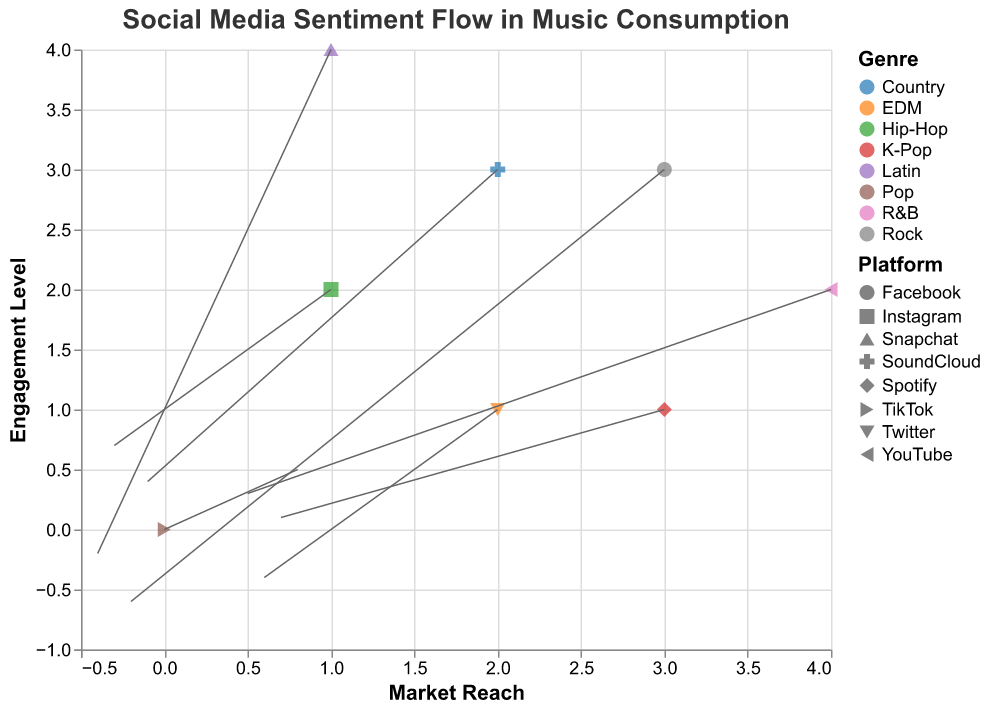Which social media platform is associated with the highest magnitude of sentiment flow? According to the tooltip of the data points, the platform associated with the highest magnitude of sentiment flow (1.2) is TikTok.
Answer: TikTok What is the direction of sentiment flow for Facebook in terms of Market Reach and Engagement Level? The data point for Facebook shows an arrow directed from (3, 3) towards negative x and y axes, meaning Market Reach decreases by 0.2 and Engagement Level decreases by 0.6.
Answer: Market Reach decreases and Engagement Level decreases Which genre shows sentiment flow with the greatest increase in Market Reach? Inspecting the U component of all genres, Pop has the greatest positive U value (0.8).
Answer: Pop How many data points have a sentiment flow magnitude over 1.0? Filtering the data points by Magnitude, we find that TikTok (Pop) with 1.2, Twitter (EDM) with 1.0, and Spotify (K-Pop) with 1.1 all exceed 1.0, yielding 3 data points.
Answer: 3 Which social media platform's sentiment flow in music consumption shows a negative change in Market Reach but a positive change in Engagement Level? Examining the U and V components of the data, Instagram (Hip-Hop) has U = -0.3 (negative change in Market Reach) and V = 0.7 (positive change in Engagement Level).
Answer: Instagram What are the Market Reach and Engagement Level coordinates where the genre K-Pop shows sentiment flow? K-Pop appears at (3, 1) according to the dataset details.
Answer: (3, 1) What is the average magnitude of sentiment flow for all genres? Summing the Magnitudes (1.2 + 0.9 + 1.0 + 0.8 + 0.7 + 0.6 + 1.1 + 0.5) gives 6.8. Dividing by the number of data points (8) results in an average of 6.8 / 8 = 0.85.
Answer: 0.85 Which genre experiences the smallest magnitude in sentiment flow? The data point with the smallest Magnitude (0.5) is for SoundCloud (Country).
Answer: Country Between Twitter and YouTube, which genre has a more significant decrease in Engagement Level? The V value for Twitter (EDM) is -0.4, while for YouTube (R&B) it is 0.3. Twitter has a more significant decrease as its V value is negative.
Answer: Twitter How does Snapchat's sentiment flow affect both Market Reach and Engagement Level? The data point for Snapchat (Latin) shows U = -0.4 and V = -0.2, indicating both Market Reach and Engagement Level decrease.
Answer: Both decrease 